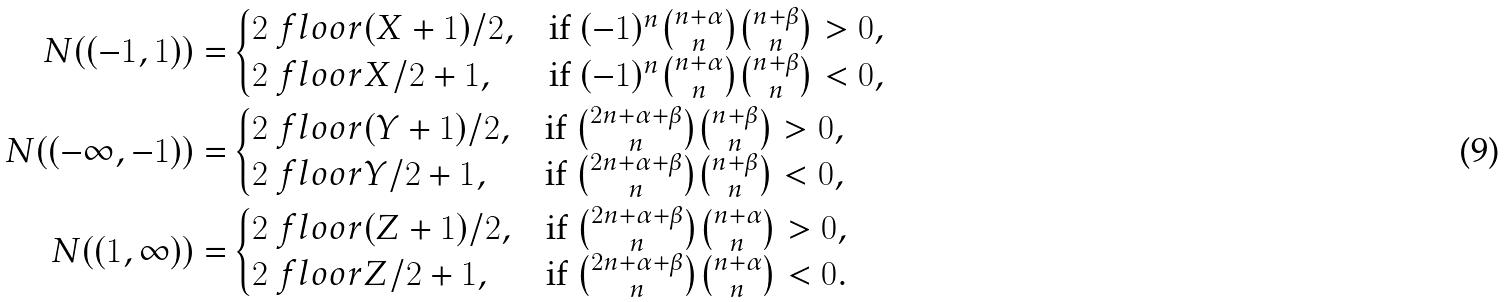<formula> <loc_0><loc_0><loc_500><loc_500>N ( ( - 1 , 1 ) ) = & \begin{cases} 2 \ f l o o r { ( X + 1 ) / 2 } , & \text {if $(-1)^{n} \binom{n+\alpha}{n} \binom{n+\beta}{n} >0$} , \\ 2 \ f l o o r { X / 2 } + 1 , & \text {if $(-1)^{n} \binom{n+\alpha}{n} \binom{n+\beta}{n} <0$} , \end{cases} \\ N ( ( - \infty , - 1 ) ) = & \begin{cases} 2 \ f l o o r { ( Y + 1 ) / 2 } , & \text {if $\binom{2n+\alpha+\beta}{n} \binom{n+\beta}{n} >0$} , \\ 2 \ f l o o r { Y / 2 } + 1 , & \text {if $\binom{2n+\alpha+\beta}{n} \binom{n+\beta}{n} <0$} , \end{cases} \\ N ( ( 1 , \infty ) ) = & \begin{cases} 2 \ f l o o r { ( Z + 1 ) / 2 } , & \text {if $\binom{2n+\alpha+\beta}{n} \binom{n+\alpha}{n} >0$} , \\ 2 \ f l o o r { Z / 2 } + 1 , & \text {if $\binom{2n+\alpha+\beta}{n} \binom{n+\alpha}{n} <0$} . \end{cases}</formula> 